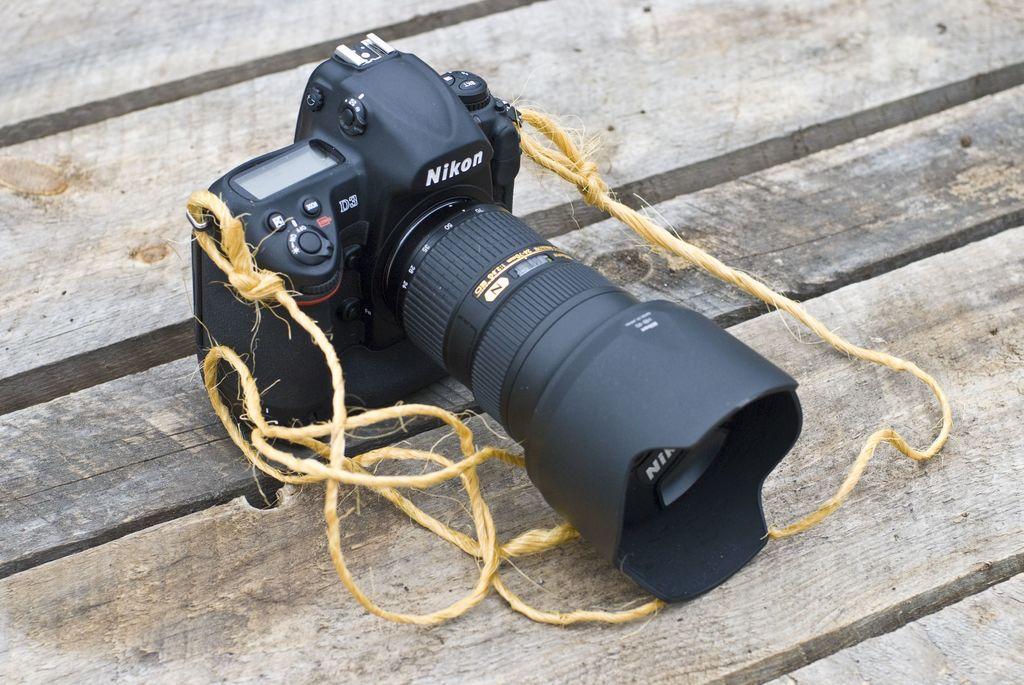Please provide a concise description of this image. We can see a camera tied with ropes to its edges and it is on a wooden platform. 